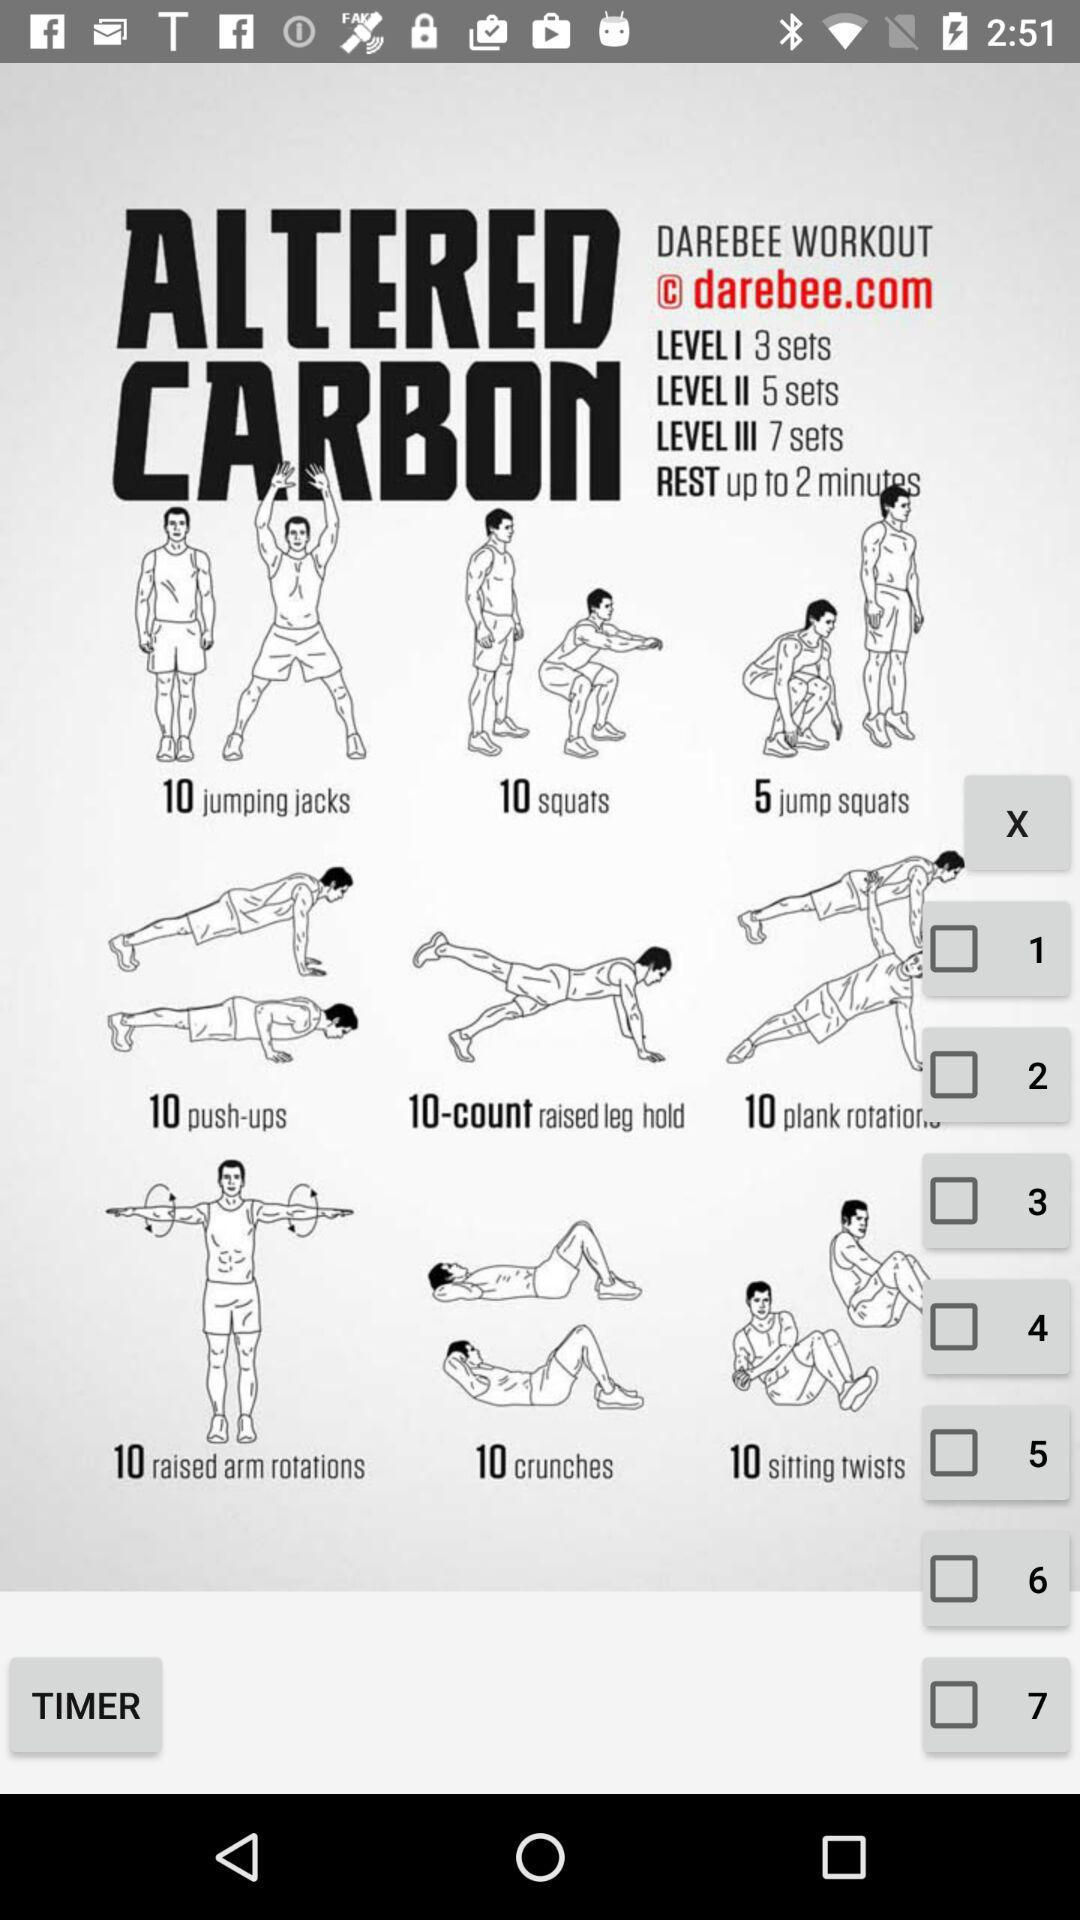What is the number of sets in Level 1? The number of sets in Level 1 is 3. 